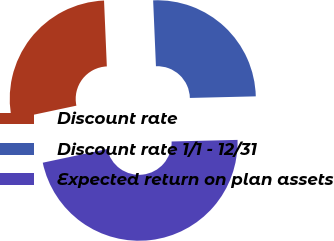Convert chart to OTSL. <chart><loc_0><loc_0><loc_500><loc_500><pie_chart><fcel>Discount rate<fcel>Discount rate 1/1 - 12/31<fcel>Expected return on plan assets<nl><fcel>27.65%<fcel>25.29%<fcel>47.06%<nl></chart> 